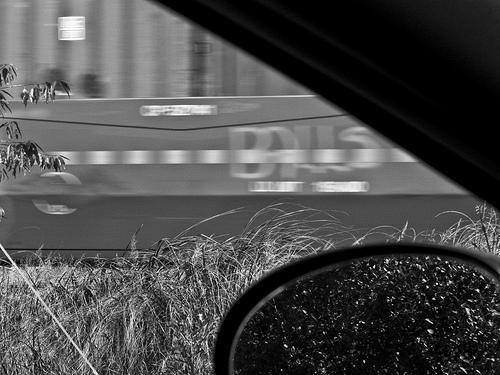How many mirrors are there?
Give a very brief answer. 1. 